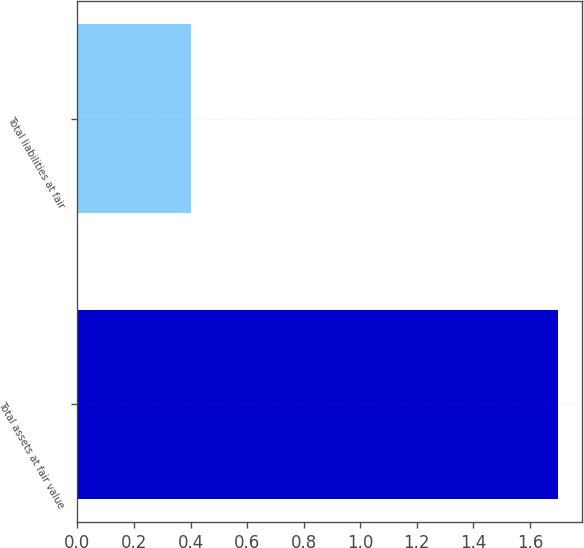Convert chart to OTSL. <chart><loc_0><loc_0><loc_500><loc_500><bar_chart><fcel>Total assets at fair value<fcel>Total liabilities at fair<nl><fcel>1.7<fcel>0.4<nl></chart> 